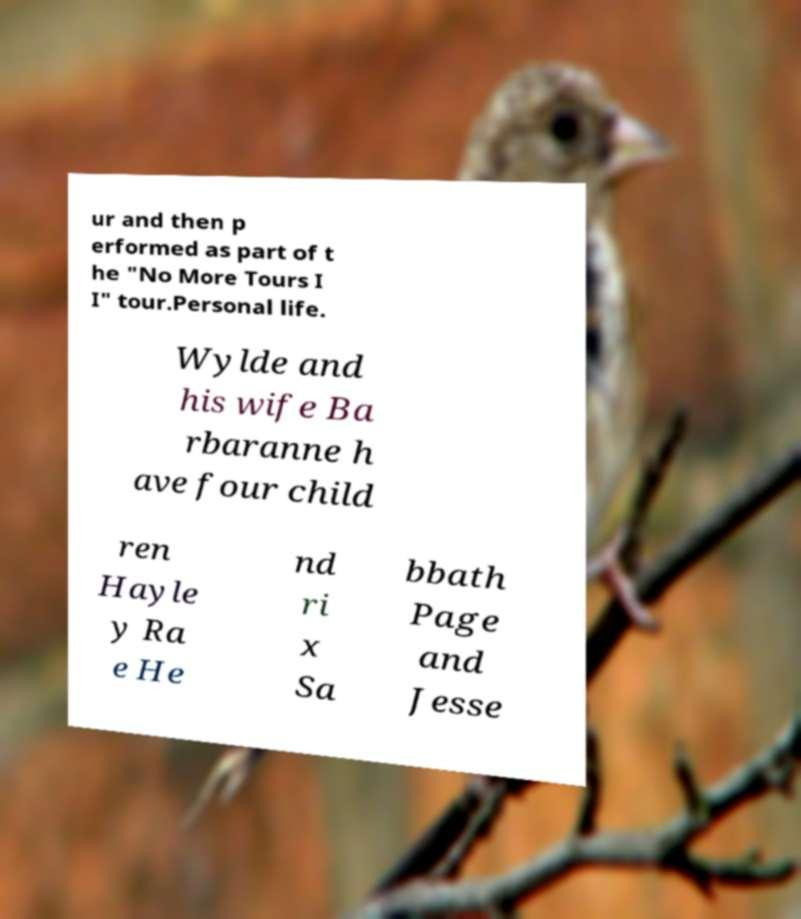I need the written content from this picture converted into text. Can you do that? ur and then p erformed as part of t he "No More Tours I I" tour.Personal life. Wylde and his wife Ba rbaranne h ave four child ren Hayle y Ra e He nd ri x Sa bbath Page and Jesse 